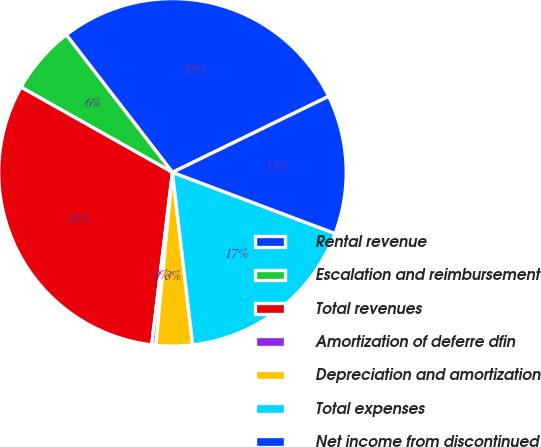Convert chart. <chart><loc_0><loc_0><loc_500><loc_500><pie_chart><fcel>Rental revenue<fcel>Escalation and reimbursement<fcel>Total revenues<fcel>Amortization of deferre dfin<fcel>Depreciation and amortization<fcel>Total expenses<fcel>Net income from discontinued<nl><fcel>28.26%<fcel>6.38%<fcel>31.25%<fcel>0.38%<fcel>3.38%<fcel>17.42%<fcel>12.93%<nl></chart> 